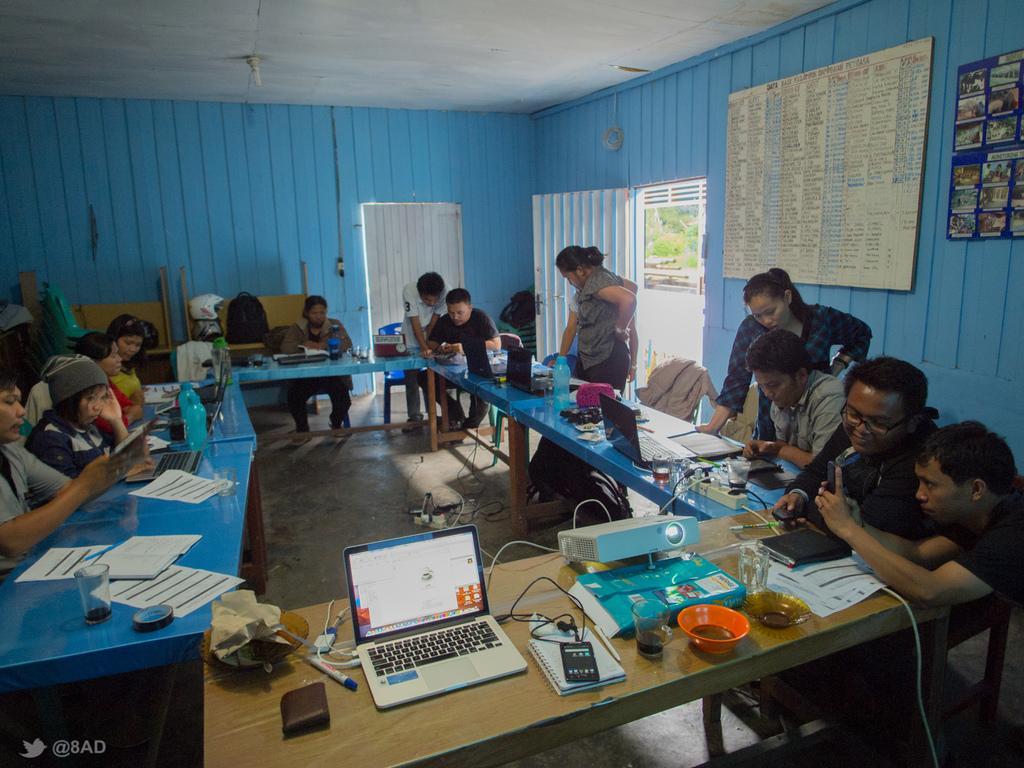Can you describe this image briefly? On the left i can see the group of persons were sitting on the chair beside the table. On the table i can see the projector machine, laptops, mobile phones, papers, bowl, cup, covers, sketch pen, water bottles, tables, sockets, water glass, wine glass, cloth, book, files, diary and other objects. On the right there is a woman who is standing near to the wall. Beside that i can see the board and photo frame. Beside her there is another woman who is standing near to the door. Through the door i can see the fencing and trees. In the bottom left corner there is a watermark. 